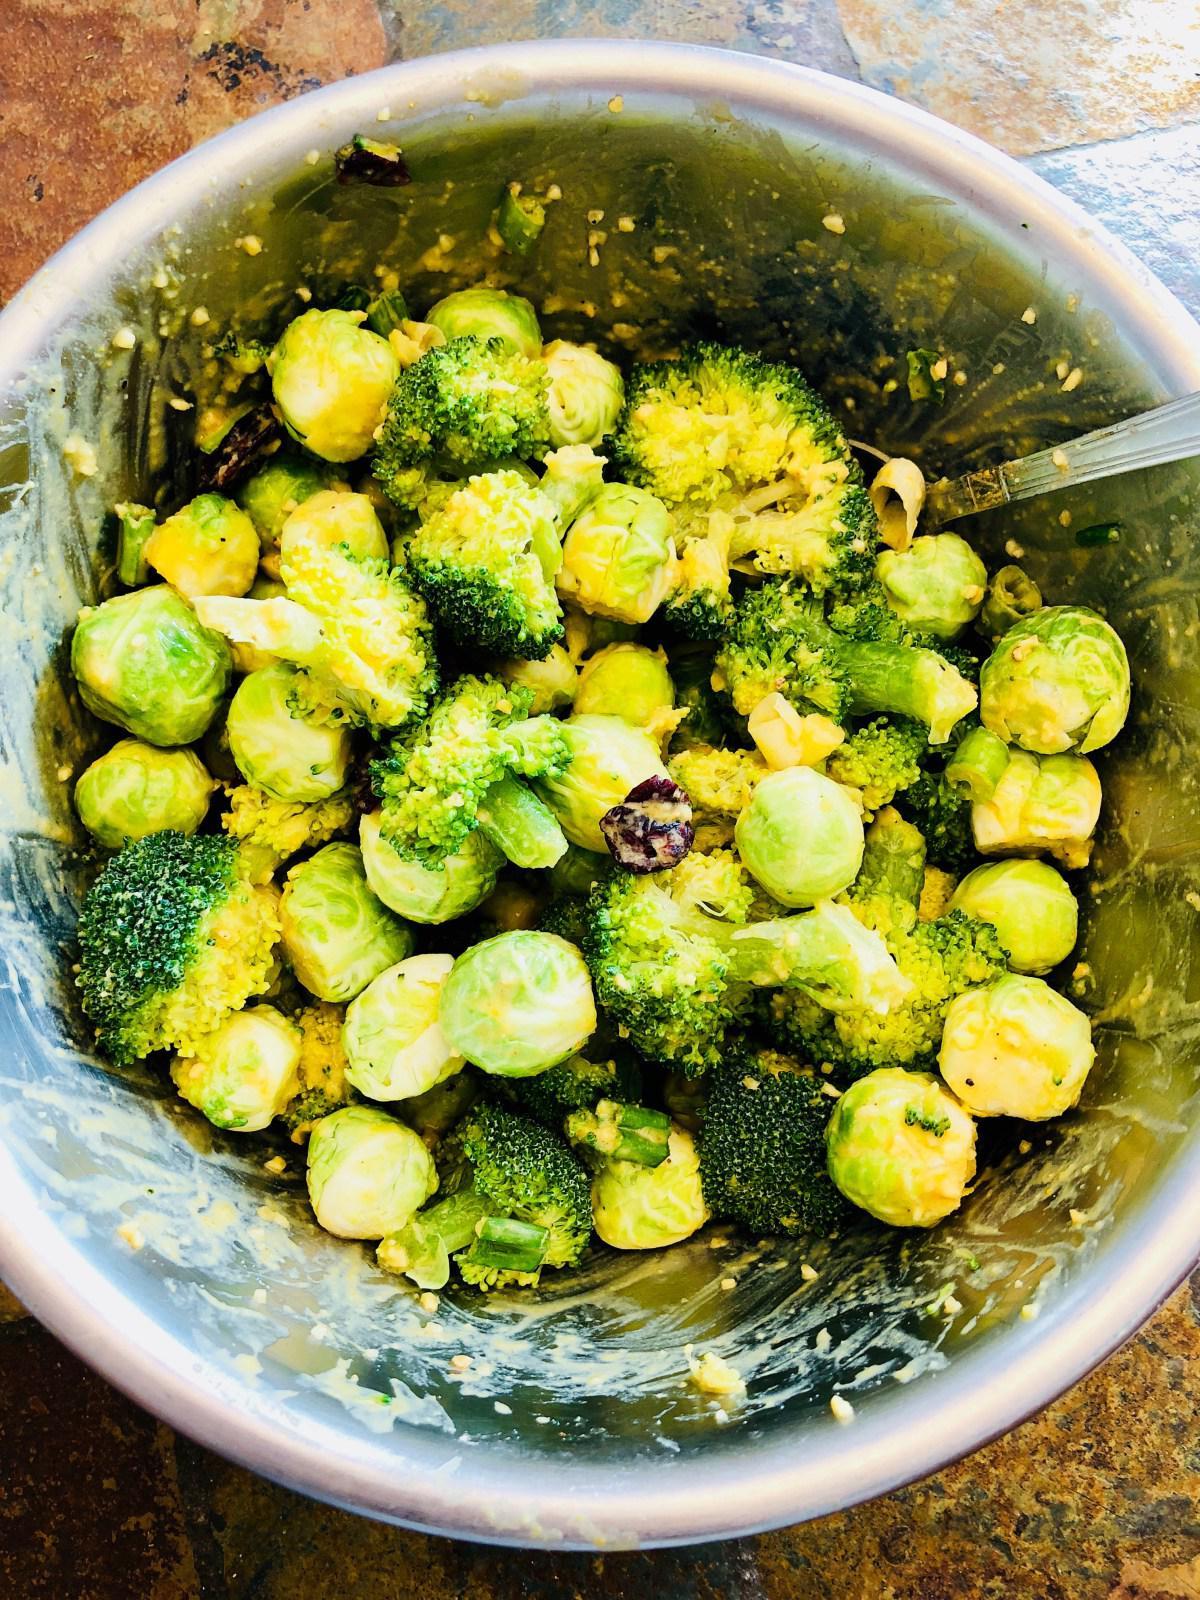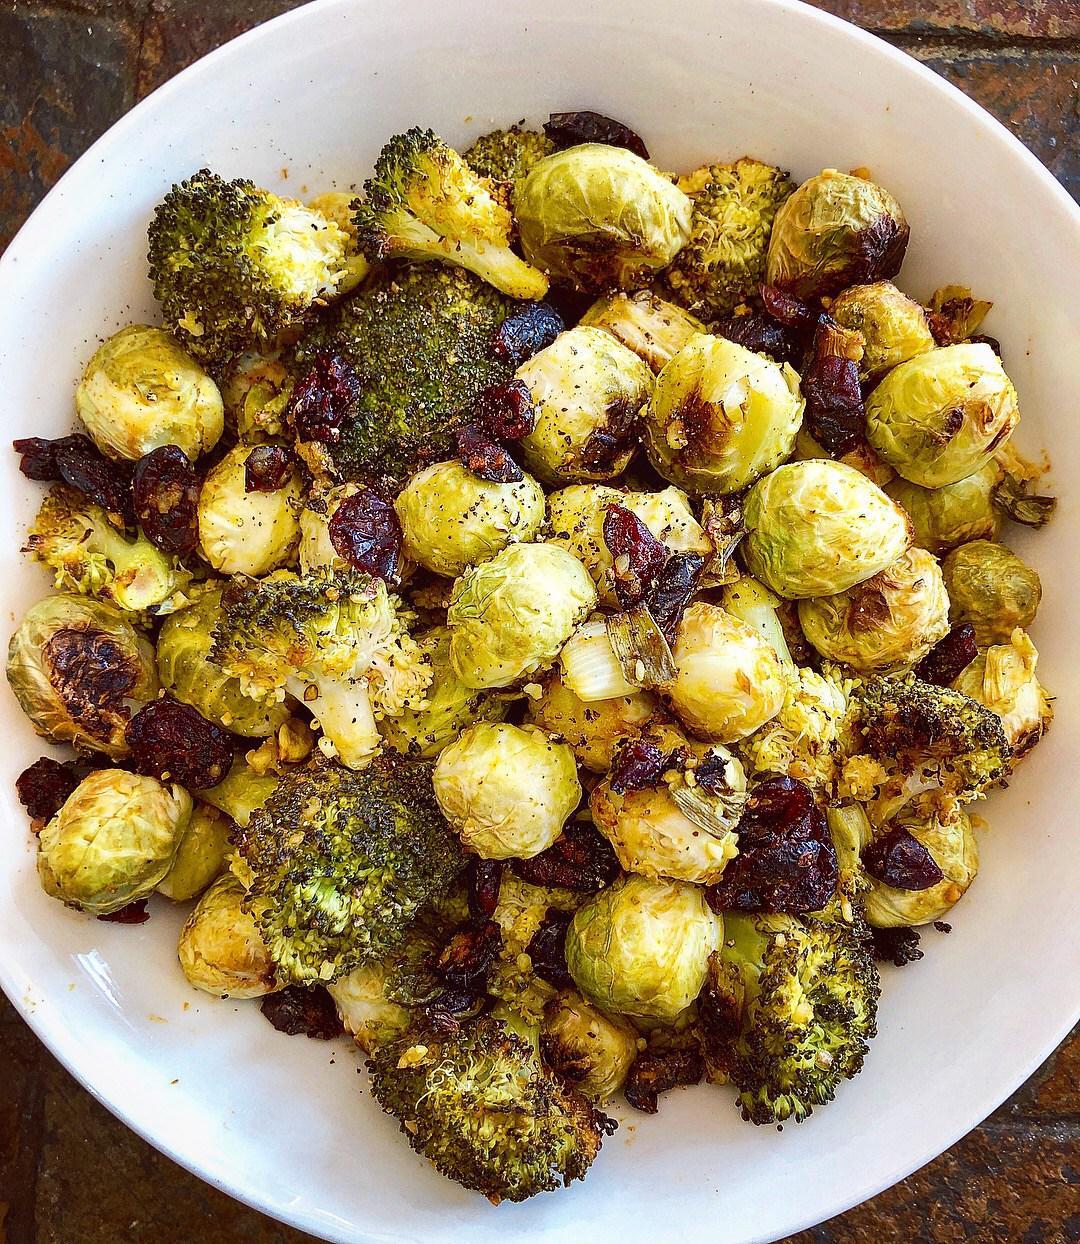The first image is the image on the left, the second image is the image on the right. For the images shown, is this caption "The food in the right image is in a solid white bowl." true? Answer yes or no. Yes. The first image is the image on the left, the second image is the image on the right. Examine the images to the left and right. Is the description "There are two bowls of broccoli." accurate? Answer yes or no. Yes. 